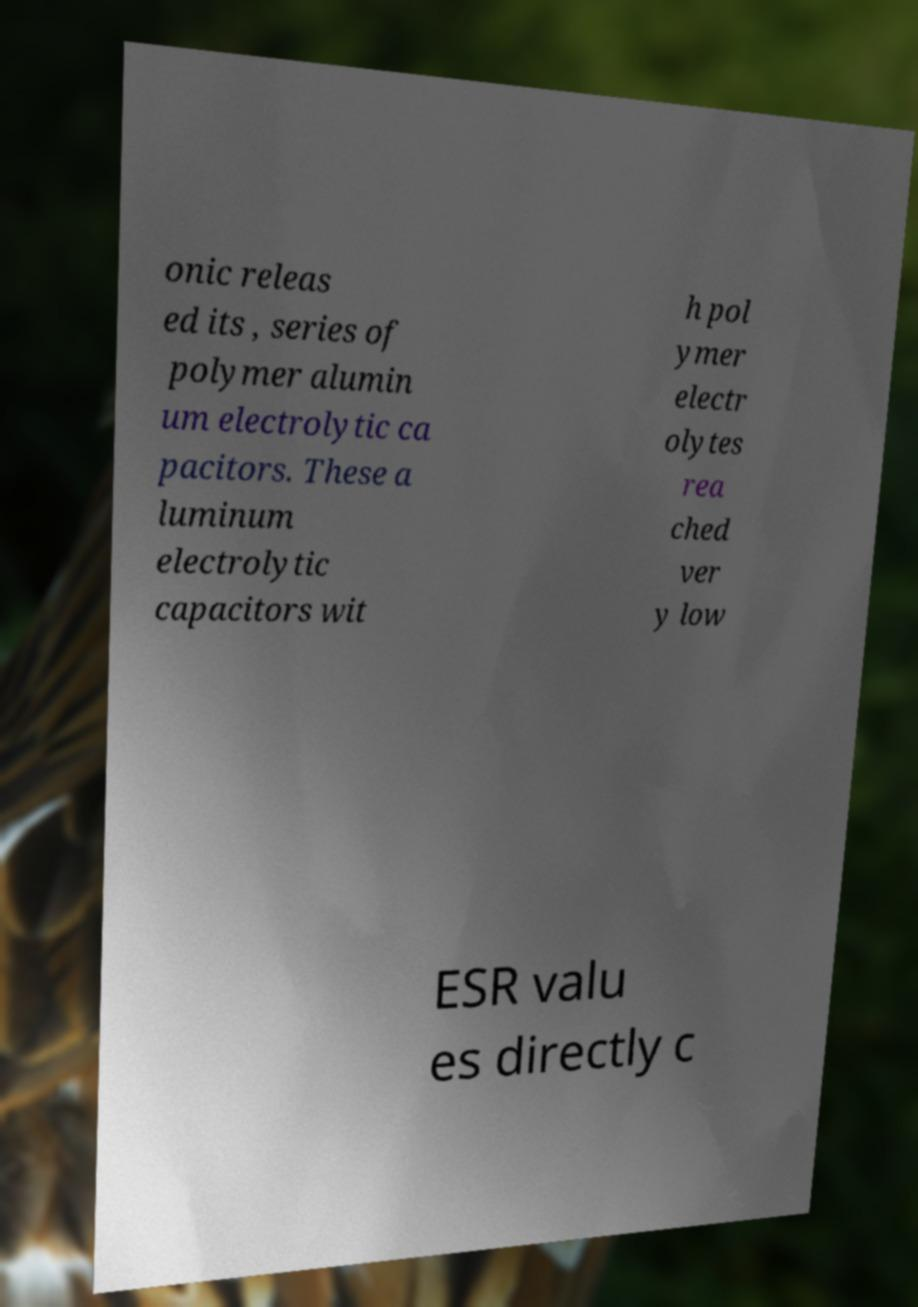There's text embedded in this image that I need extracted. Can you transcribe it verbatim? onic releas ed its , series of polymer alumin um electrolytic ca pacitors. These a luminum electrolytic capacitors wit h pol ymer electr olytes rea ched ver y low ESR valu es directly c 